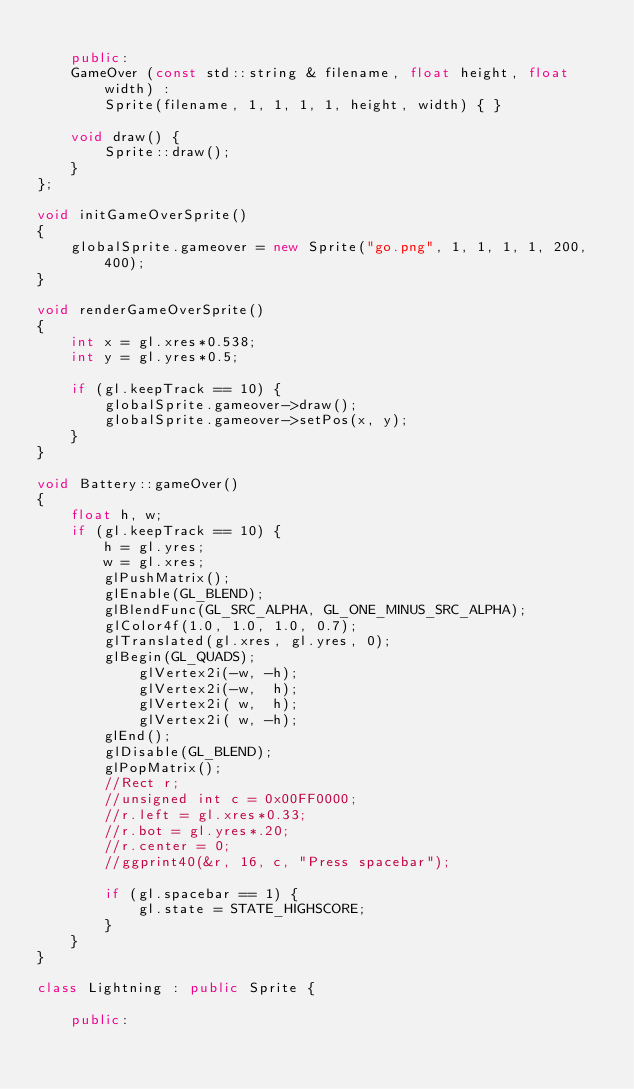<code> <loc_0><loc_0><loc_500><loc_500><_C++_>	
	public:
	GameOver (const std::string & filename, float height, float width) :
		Sprite(filename, 1, 1, 1, 1, height, width) { }

	void draw() {
		Sprite::draw();
	}
};

void initGameOverSprite()
{
	globalSprite.gameover = new Sprite("go.png", 1, 1, 1, 1, 200, 400);
}

void renderGameOverSprite()
{     
	int x = gl.xres*0.538;  
	int y = gl.yres*0.5;  

	if (gl.keepTrack == 10) {
		globalSprite.gameover->draw();
		globalSprite.gameover->setPos(x, y);
	}
}

void Battery::gameOver()
{
	float h, w;
	if (gl.keepTrack == 10) {
		h = gl.yres;
		w = gl.xres;
		glPushMatrix();
		glEnable(GL_BLEND);
		glBlendFunc(GL_SRC_ALPHA, GL_ONE_MINUS_SRC_ALPHA);
		glColor4f(1.0, 1.0, 1.0, 0.7);
		glTranslated(gl.xres, gl.yres, 0);
		glBegin(GL_QUADS);
			glVertex2i(-w, -h);
			glVertex2i(-w,  h);
			glVertex2i( w,  h);
			glVertex2i( w, -h);
		glEnd();
		glDisable(GL_BLEND);
		glPopMatrix();
		//Rect r;
		//unsigned int c = 0x00FF0000;
		//r.left = gl.xres*0.33; 
		//r.bot = gl.yres*.20;  
		//r.center = 0;
		//ggprint40(&r, 16, c, "Press spacebar");
	
		if (gl.spacebar == 1) {
			gl.state = STATE_HIGHSCORE;
		}
	}
}

class Lightning : public Sprite {
	
	public:</code> 